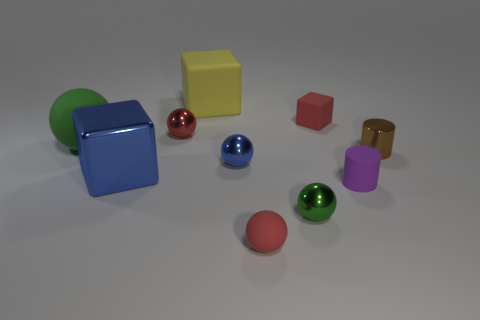There is a large green thing; what shape is it?
Your response must be concise. Sphere. Do the cylinder in front of the big shiny thing and the tiny red ball behind the tiny brown cylinder have the same material?
Offer a very short reply. No. The green object that is on the right side of the large sphere has what shape?
Your response must be concise. Sphere. There is another green object that is the same shape as the small green thing; what is its size?
Offer a very short reply. Large. Do the small matte ball and the small matte cube have the same color?
Your answer should be compact. Yes. Are there any shiny things to the right of the tiny rubber thing behind the purple rubber thing?
Offer a very short reply. Yes. What color is the small matte object that is the same shape as the tiny blue metal object?
Offer a terse response. Red. What number of small rubber things are the same color as the tiny matte block?
Ensure brevity in your answer.  1. There is a big object that is behind the rubber ball that is behind the rubber object in front of the tiny green metallic thing; what color is it?
Provide a succinct answer. Yellow. Do the tiny block and the small purple cylinder have the same material?
Offer a very short reply. Yes. 